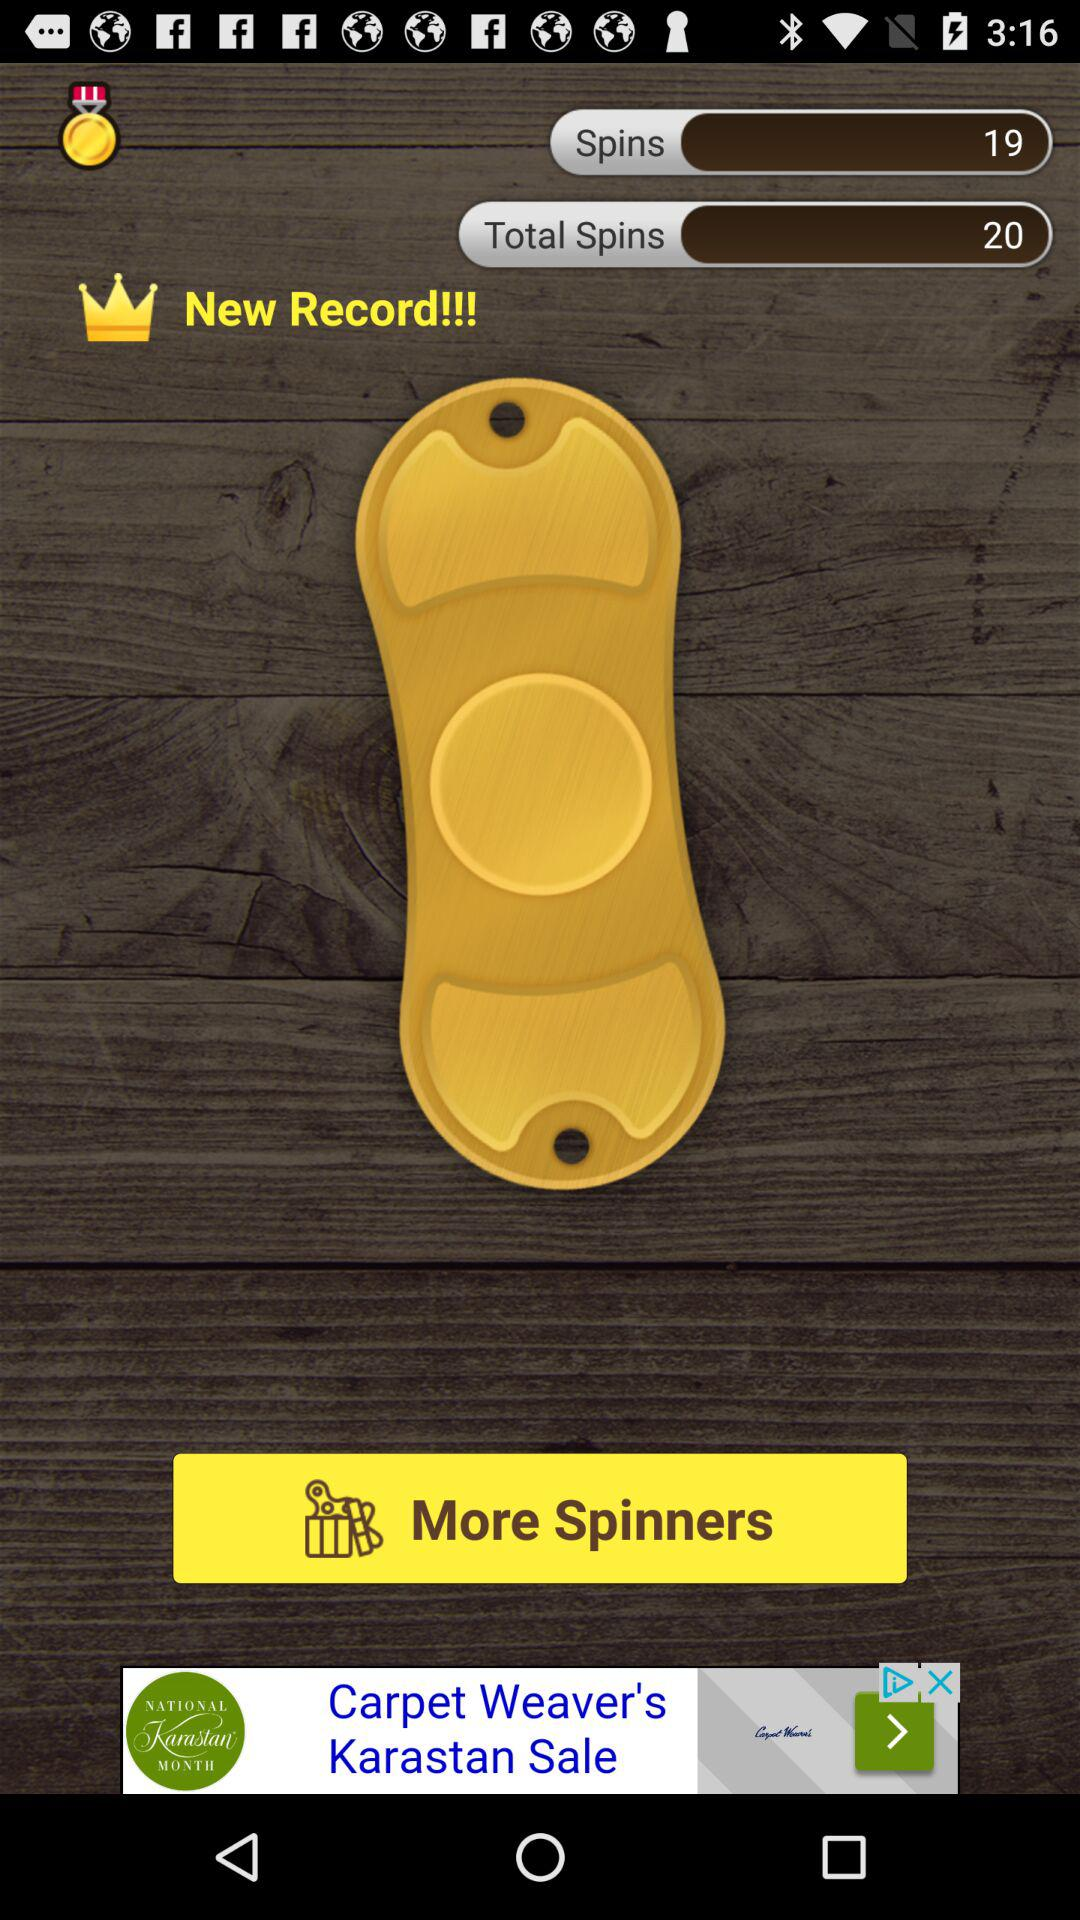How many spins do I have in total?
Answer the question using a single word or phrase. 20 